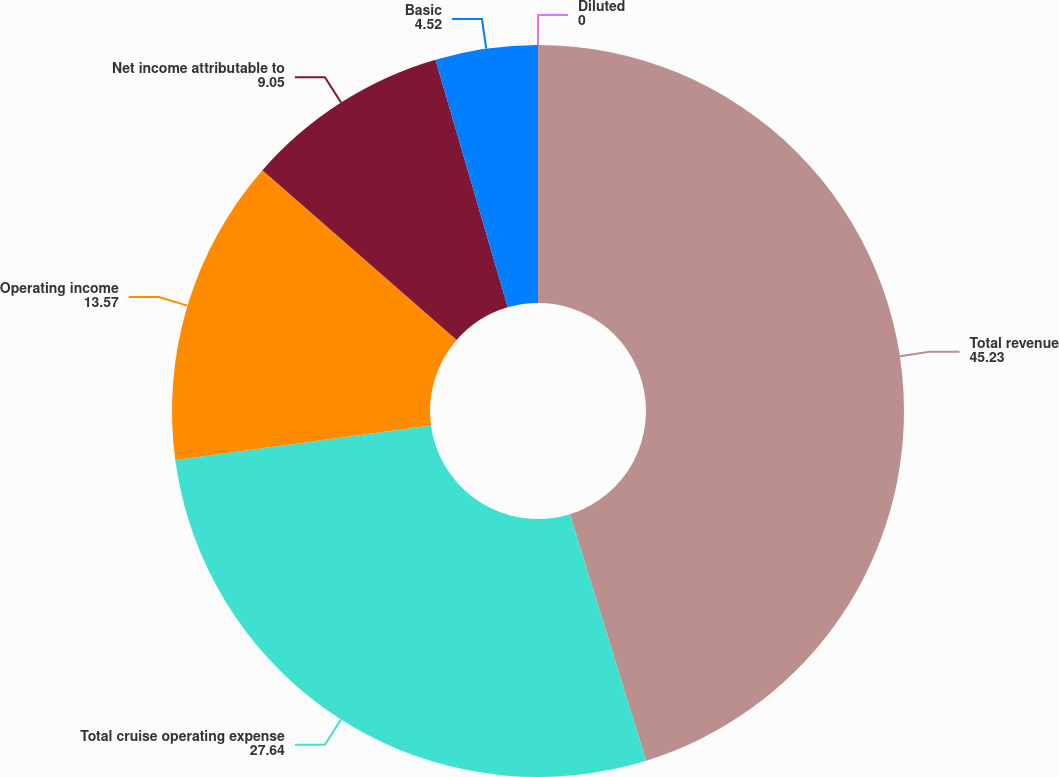Convert chart to OTSL. <chart><loc_0><loc_0><loc_500><loc_500><pie_chart><fcel>Total revenue<fcel>Total cruise operating expense<fcel>Operating income<fcel>Net income attributable to<fcel>Basic<fcel>Diluted<nl><fcel>45.23%<fcel>27.64%<fcel>13.57%<fcel>9.05%<fcel>4.52%<fcel>0.0%<nl></chart> 